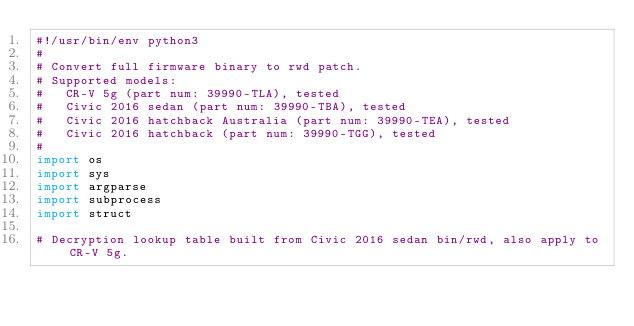Convert code to text. <code><loc_0><loc_0><loc_500><loc_500><_Python_>#!/usr/bin/env python3
#
# Convert full firmware binary to rwd patch.
# Supported models:
#   CR-V 5g (part num: 39990-TLA), tested
#   Civic 2016 sedan (part num: 39990-TBA), tested
#   Civic 2016 hatchback Australia (part num: 39990-TEA), tested
#   Civic 2016 hatchback (part num: 39990-TGG), tested
#
import os
import sys
import argparse
import subprocess
import struct

# Decryption lookup table built from Civic 2016 sedan bin/rwd, also apply to CR-V 5g.</code> 